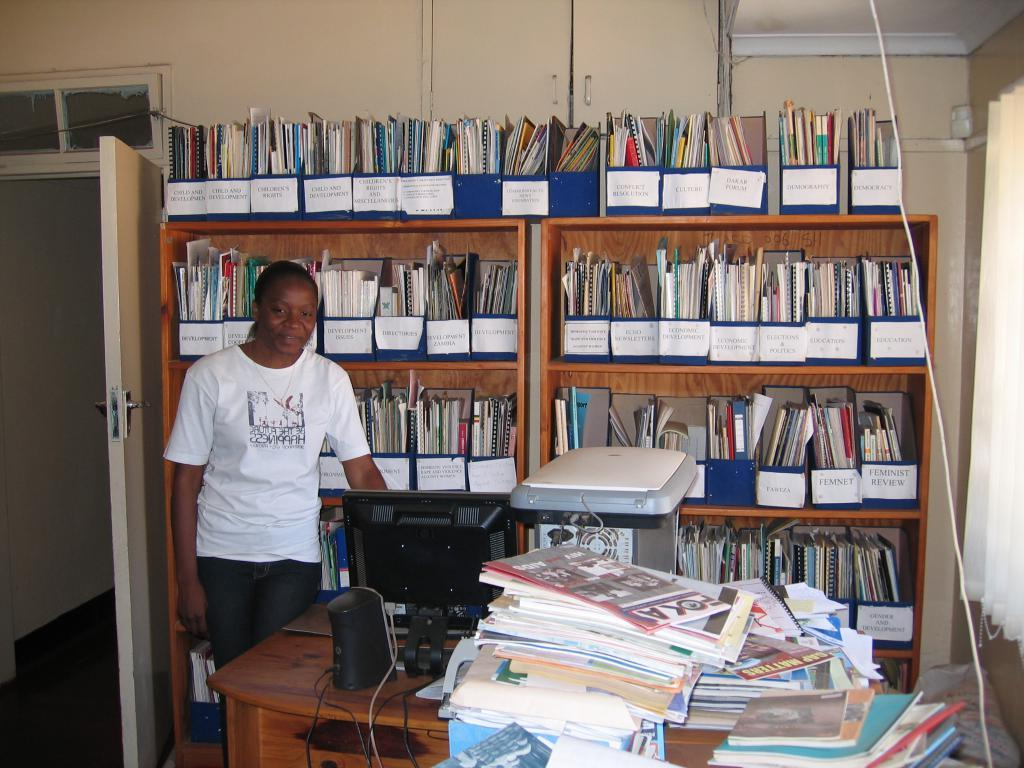<image>
Give a short and clear explanation of the subsequent image. A person is wearing a shirt that mentions happiness on the front. 